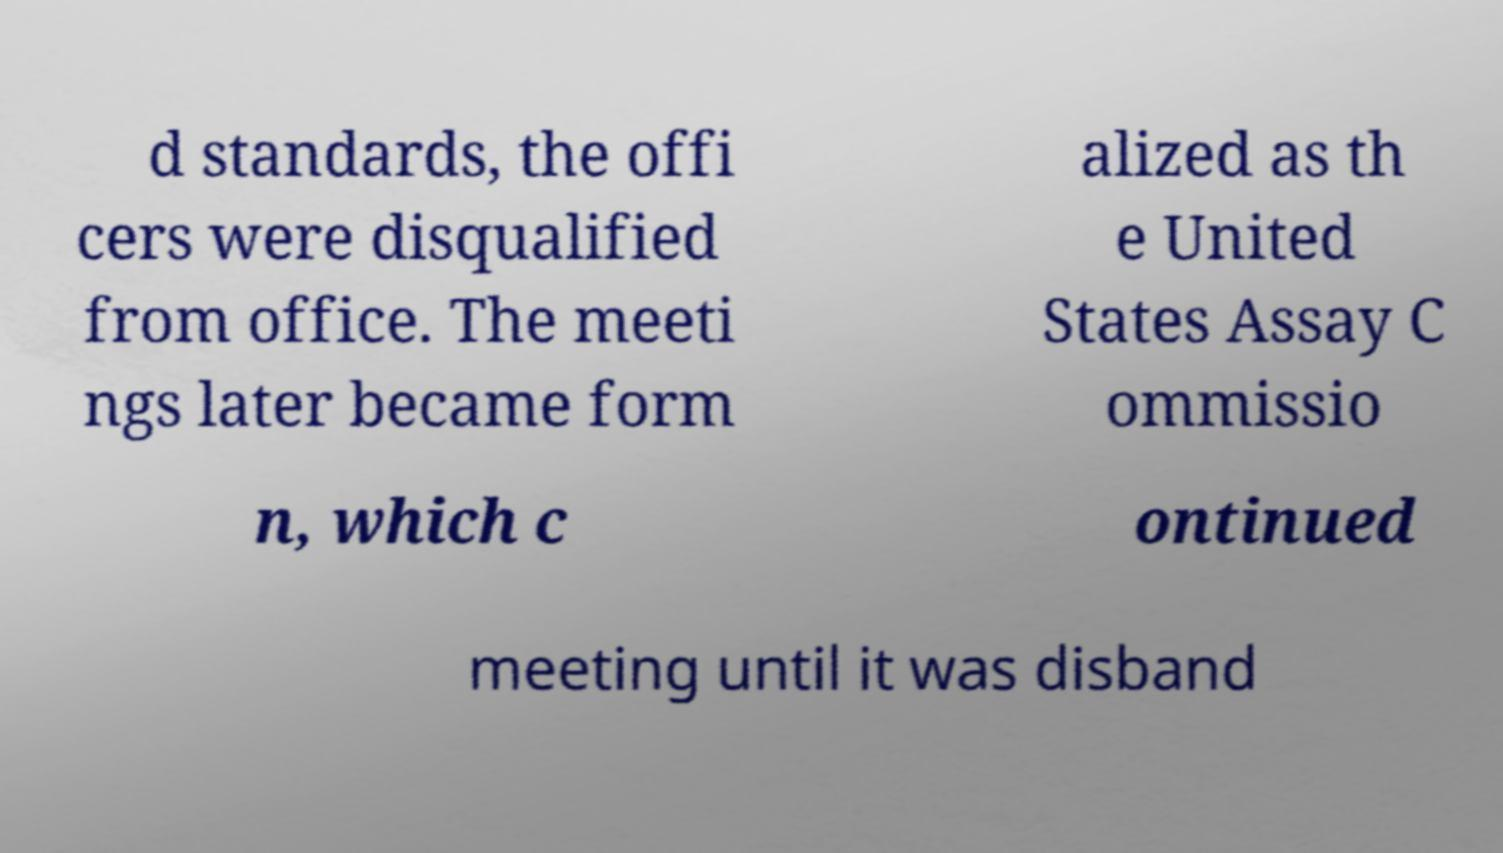Could you assist in decoding the text presented in this image and type it out clearly? d standards, the offi cers were disqualified from office. The meeti ngs later became form alized as th e United States Assay C ommissio n, which c ontinued meeting until it was disband 